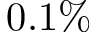<formula> <loc_0><loc_0><loc_500><loc_500>0 . 1 \%</formula> 